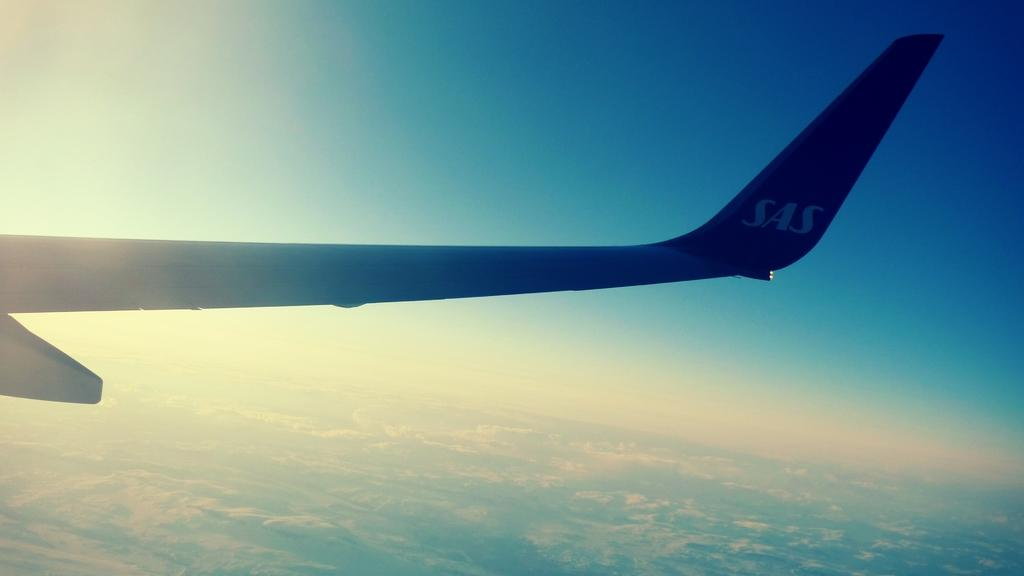<image>
Present a compact description of the photo's key features. An airplane with SAS on the tail flies through a blue, sunny sky. 